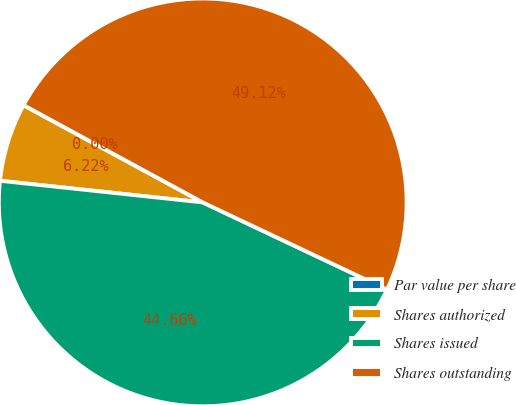<chart> <loc_0><loc_0><loc_500><loc_500><pie_chart><fcel>Par value per share<fcel>Shares authorized<fcel>Shares issued<fcel>Shares outstanding<nl><fcel>0.0%<fcel>6.22%<fcel>44.66%<fcel>49.12%<nl></chart> 